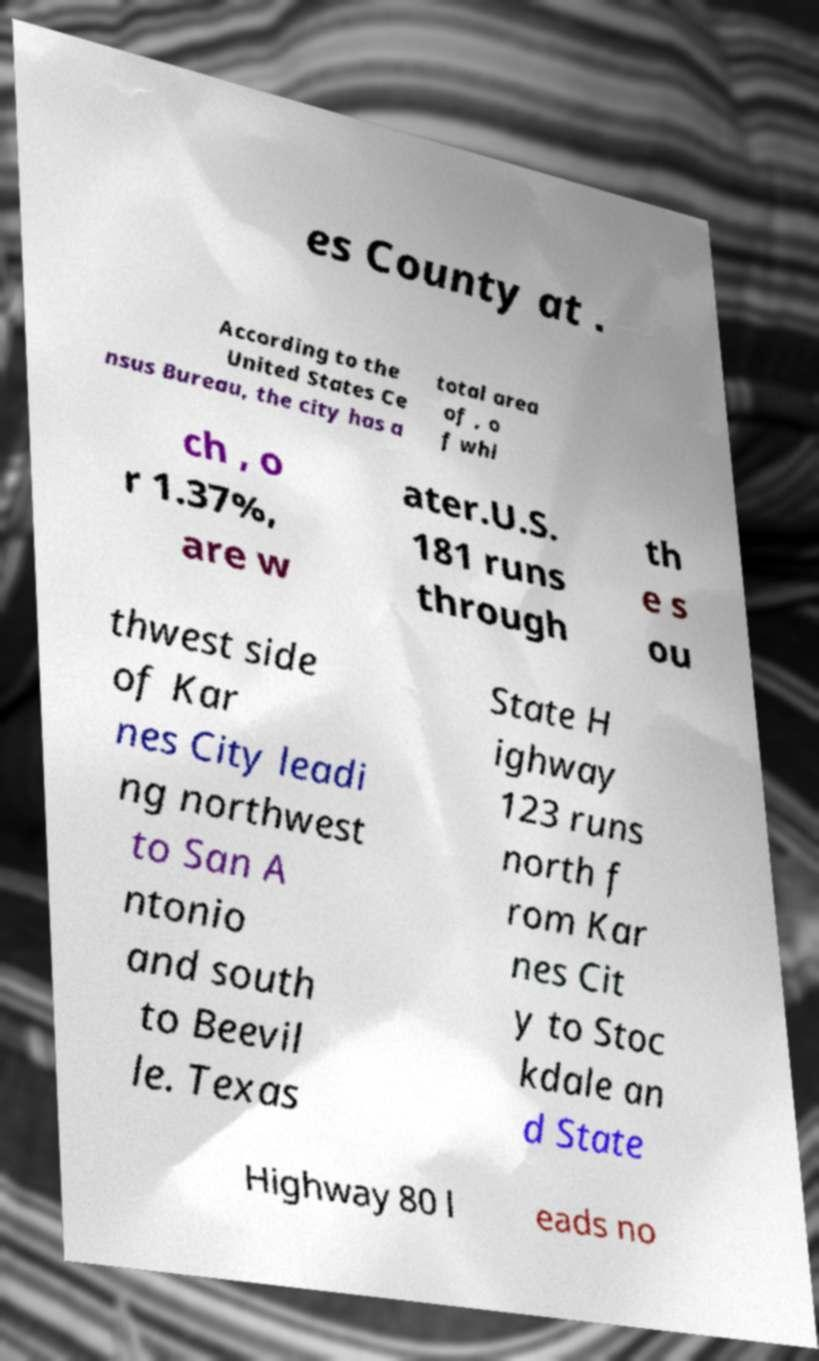Please read and relay the text visible in this image. What does it say? es County at . According to the United States Ce nsus Bureau, the city has a total area of , o f whi ch , o r 1.37%, are w ater.U.S. 181 runs through th e s ou thwest side of Kar nes City leadi ng northwest to San A ntonio and south to Beevil le. Texas State H ighway 123 runs north f rom Kar nes Cit y to Stoc kdale an d State Highway 80 l eads no 